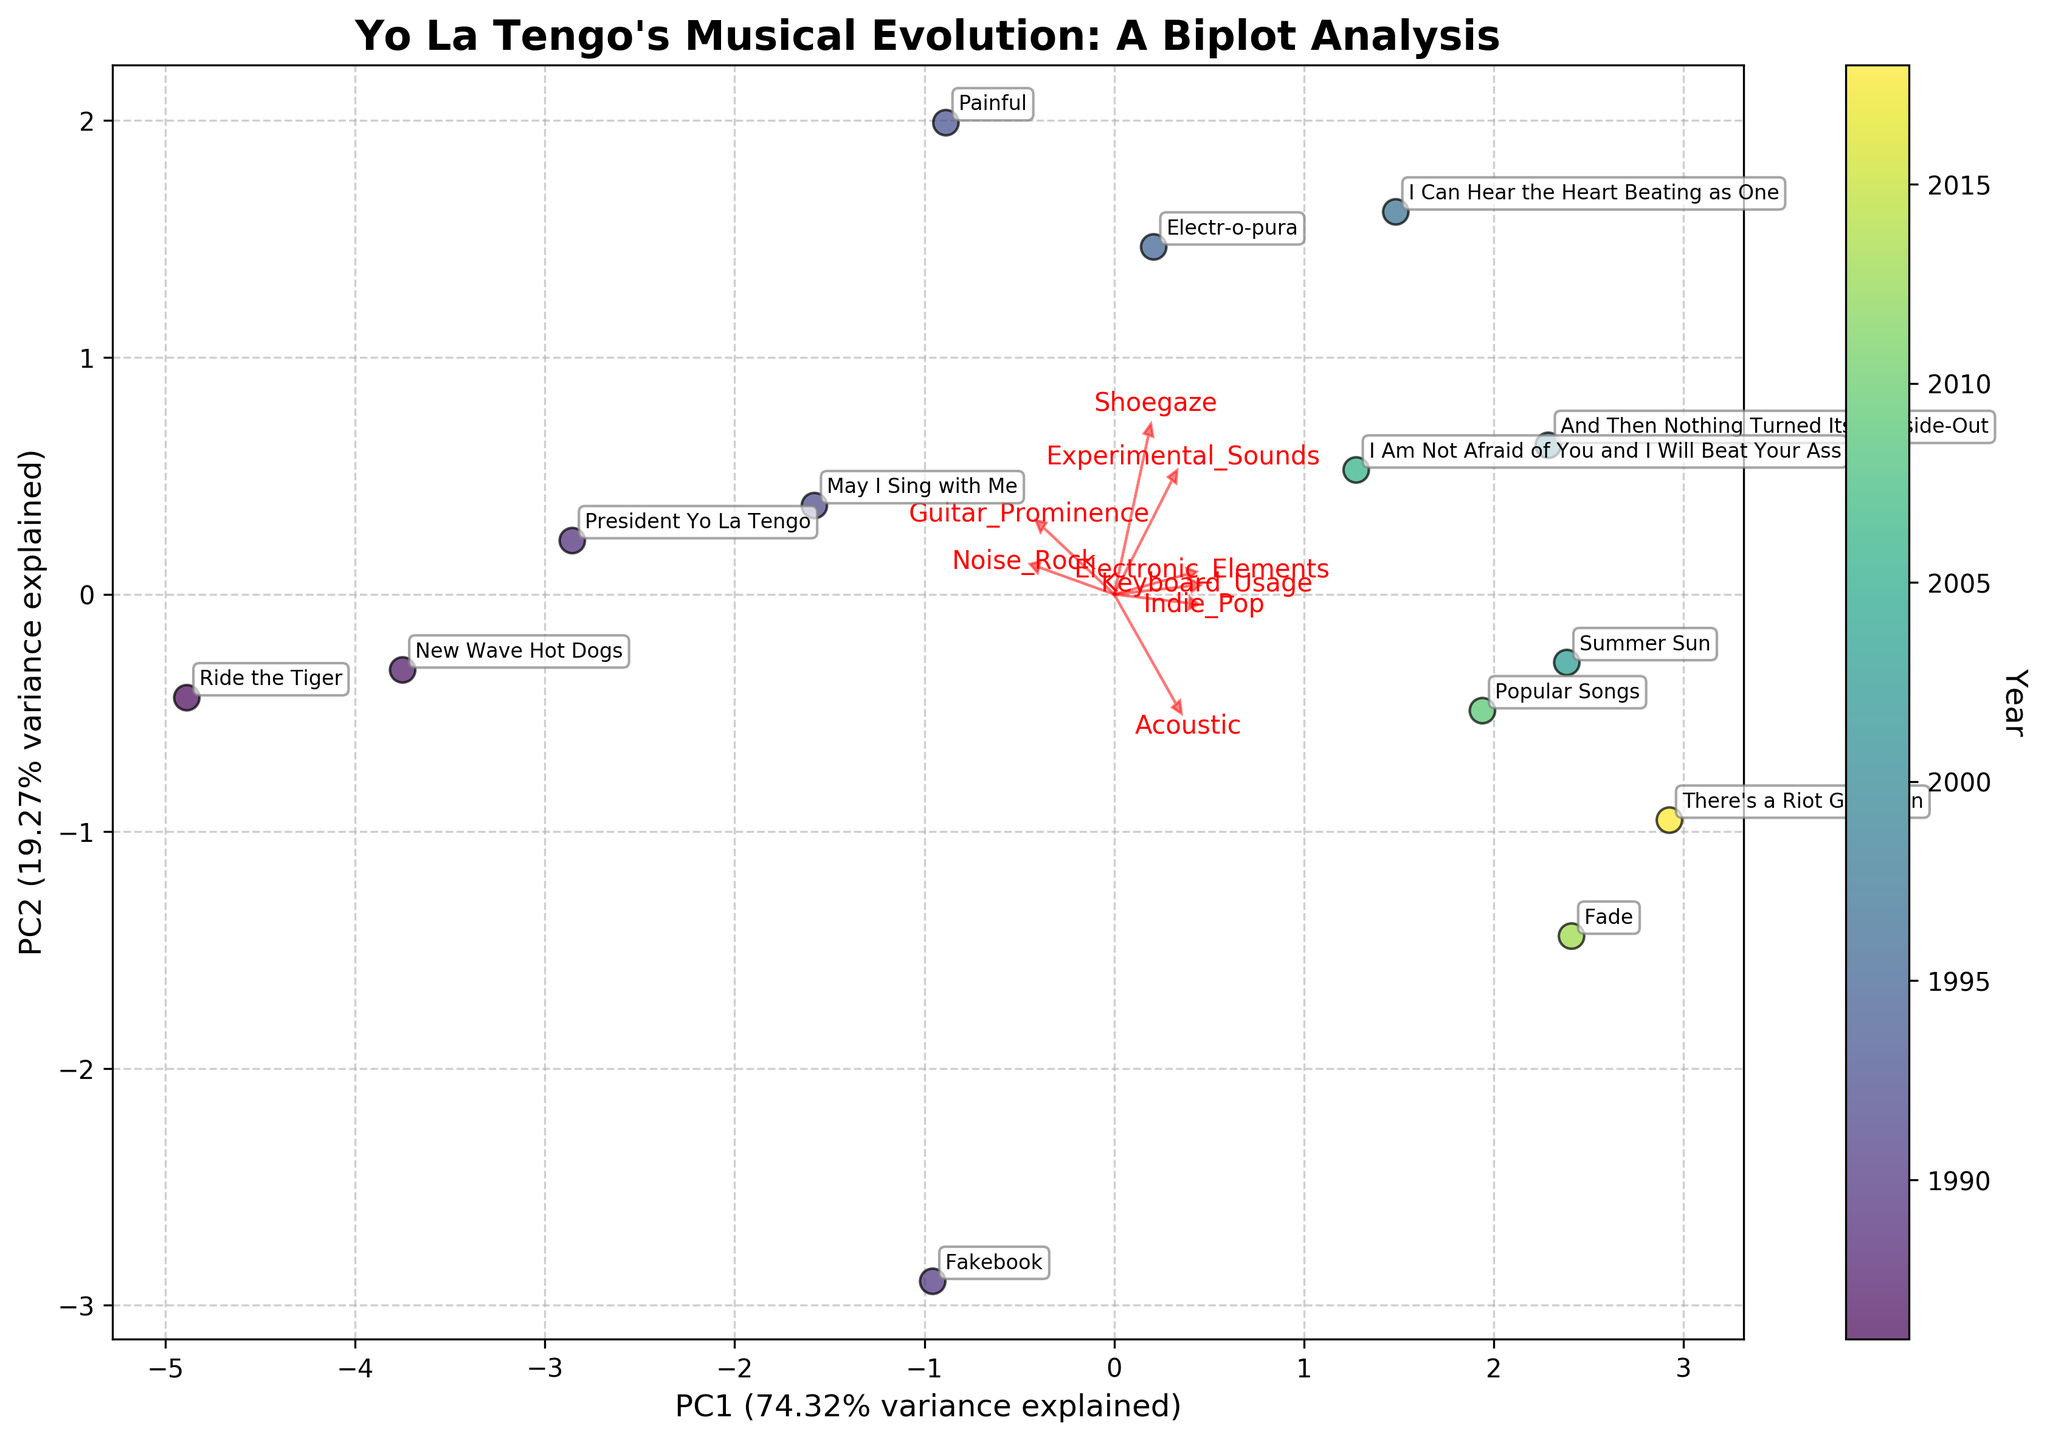What's the title of the plot? The title is located at the top of the figure, typically written in bold and larger font size. It explains what the figure is about.
Answer: Yo La Tengo's Musical Evolution: A Biplot Analysis What does the color of the data points represent? The color of the data points is shown in the colorbar on the right side of the plot, indicating that it represents the 'Year'.
Answer: The year each album was released Which album is closest to the arrow indicating 'Guitar_Prominence'? The arrows show the direction and magnitude of the features. The album nearest to the 'Guitar_Prominence' arrow head would visually appear closest to that direction.
Answer: Ride the Tiger Which feature has the longest arrow in the biplot, indicating its significant contribution to the principal components? By checking the length of the arrows, the feature with the longest arrow from the origin indicates the strongest contribution.
Answer: Keyboard_Usage How did the 'Acoustic' elements trend from the earliest to the latest albums? You can see the trend by following the general direction of the data points over time while observing their relative positions concerning the 'Acoustic' arrow.
Answer: Increased Which albums have the highest 'Experimental_Sounds' according to their positioning in the biplot? Albums near or in the direction of the 'Experimental_Sounds' arrow have higher values of that feature.
Answer: I Can Hear the Heart Beating as One, Electr-o-Pura What percentage of variance is explained by PC1? The x-axis label indicates the percentage of variance explained by PC1, usually in parenthesis after the axis name.
Answer: 34% What is the difference in positioning of 'New Wave Hot Dogs' vs 'Popular Songs' on PC1? Locate the positions of 'New Wave Hot Dogs' and 'Popular Songs' on the x-axis (PC1) and find the difference between their x-coordinates.
Answer: 'New Wave Hot Dogs' is to the left of 'Popular Songs', indicating a lower PC1 value How is 'Electronic_Elements' visually represented in the dataset? By observing the direction and spread of the data points in relation to the 'Electronic_Elements' arrow, you can infer the presence and trend in electronic elements across the albums.
Answer: Increasing in later albums How do 'Indie_Pop' and 'Noise_Rock' elements compare across the early and later albums? By examining the direction from early data points to later ones with respect to 'Indie_Pop' and 'Noise_Rock' arrows, you can see how these elements' influence changes over time.
Answer: 'Indie_Pop' increases while 'Noise_Rock' decreases 